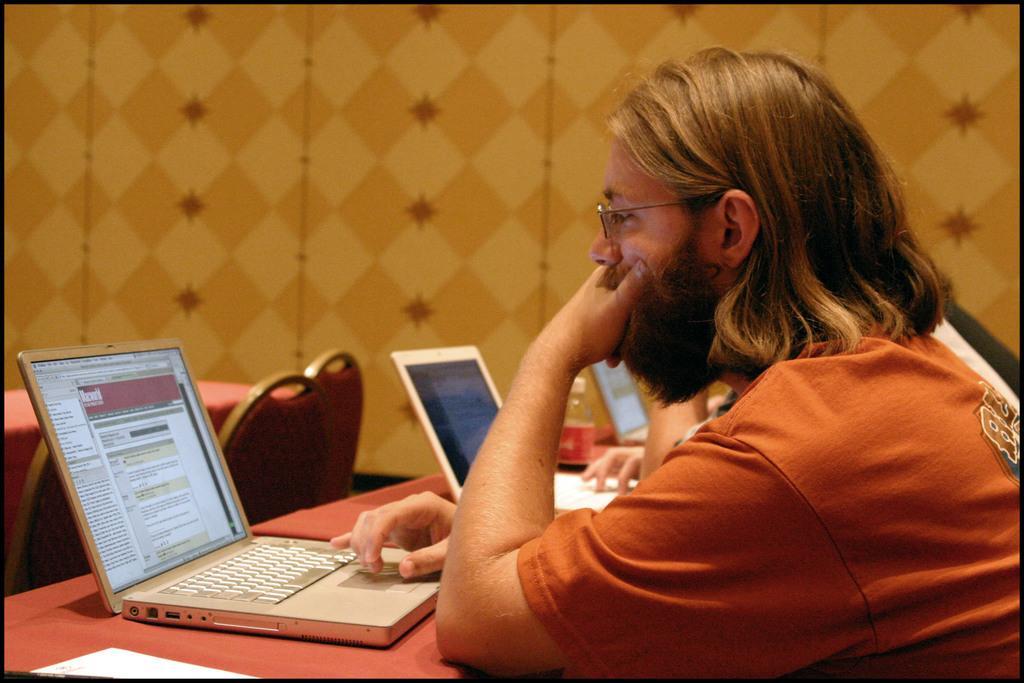In one or two sentences, can you explain what this image depicts? In this image, we can see a person is looking towards the laptop screen. Here we can see laptops, human hand, fingers, bottle, chairs, tables and wall. 